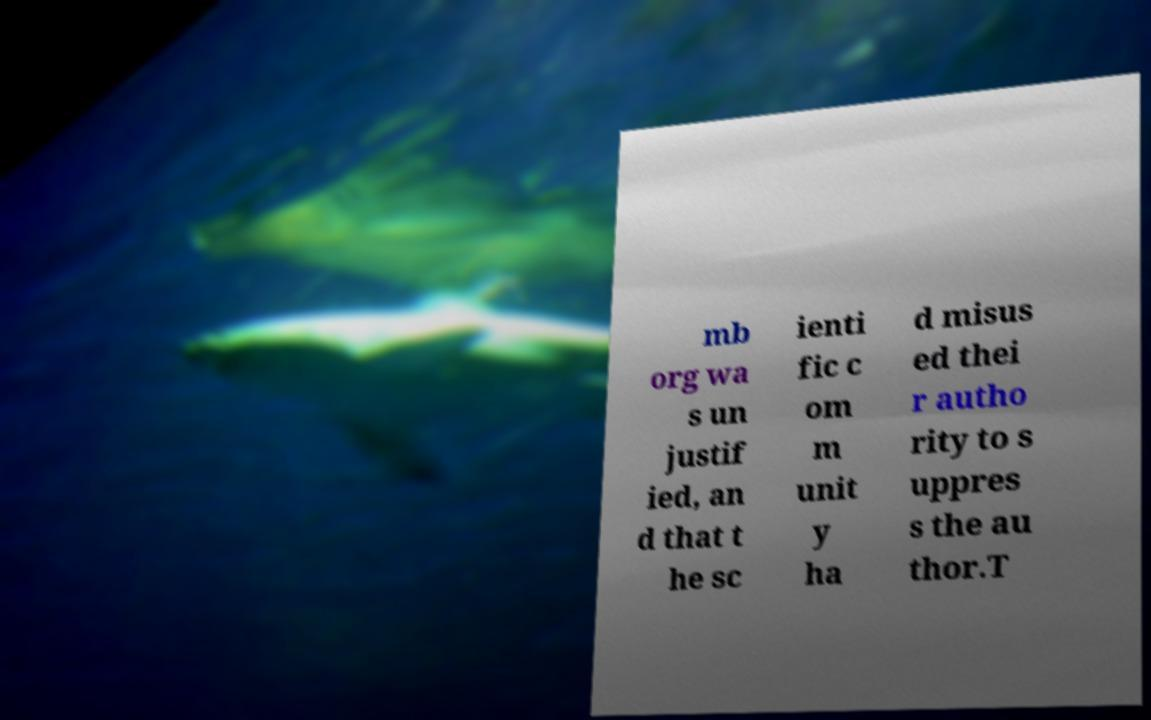Please identify and transcribe the text found in this image. mb org wa s un justif ied, an d that t he sc ienti fic c om m unit y ha d misus ed thei r autho rity to s uppres s the au thor.T 